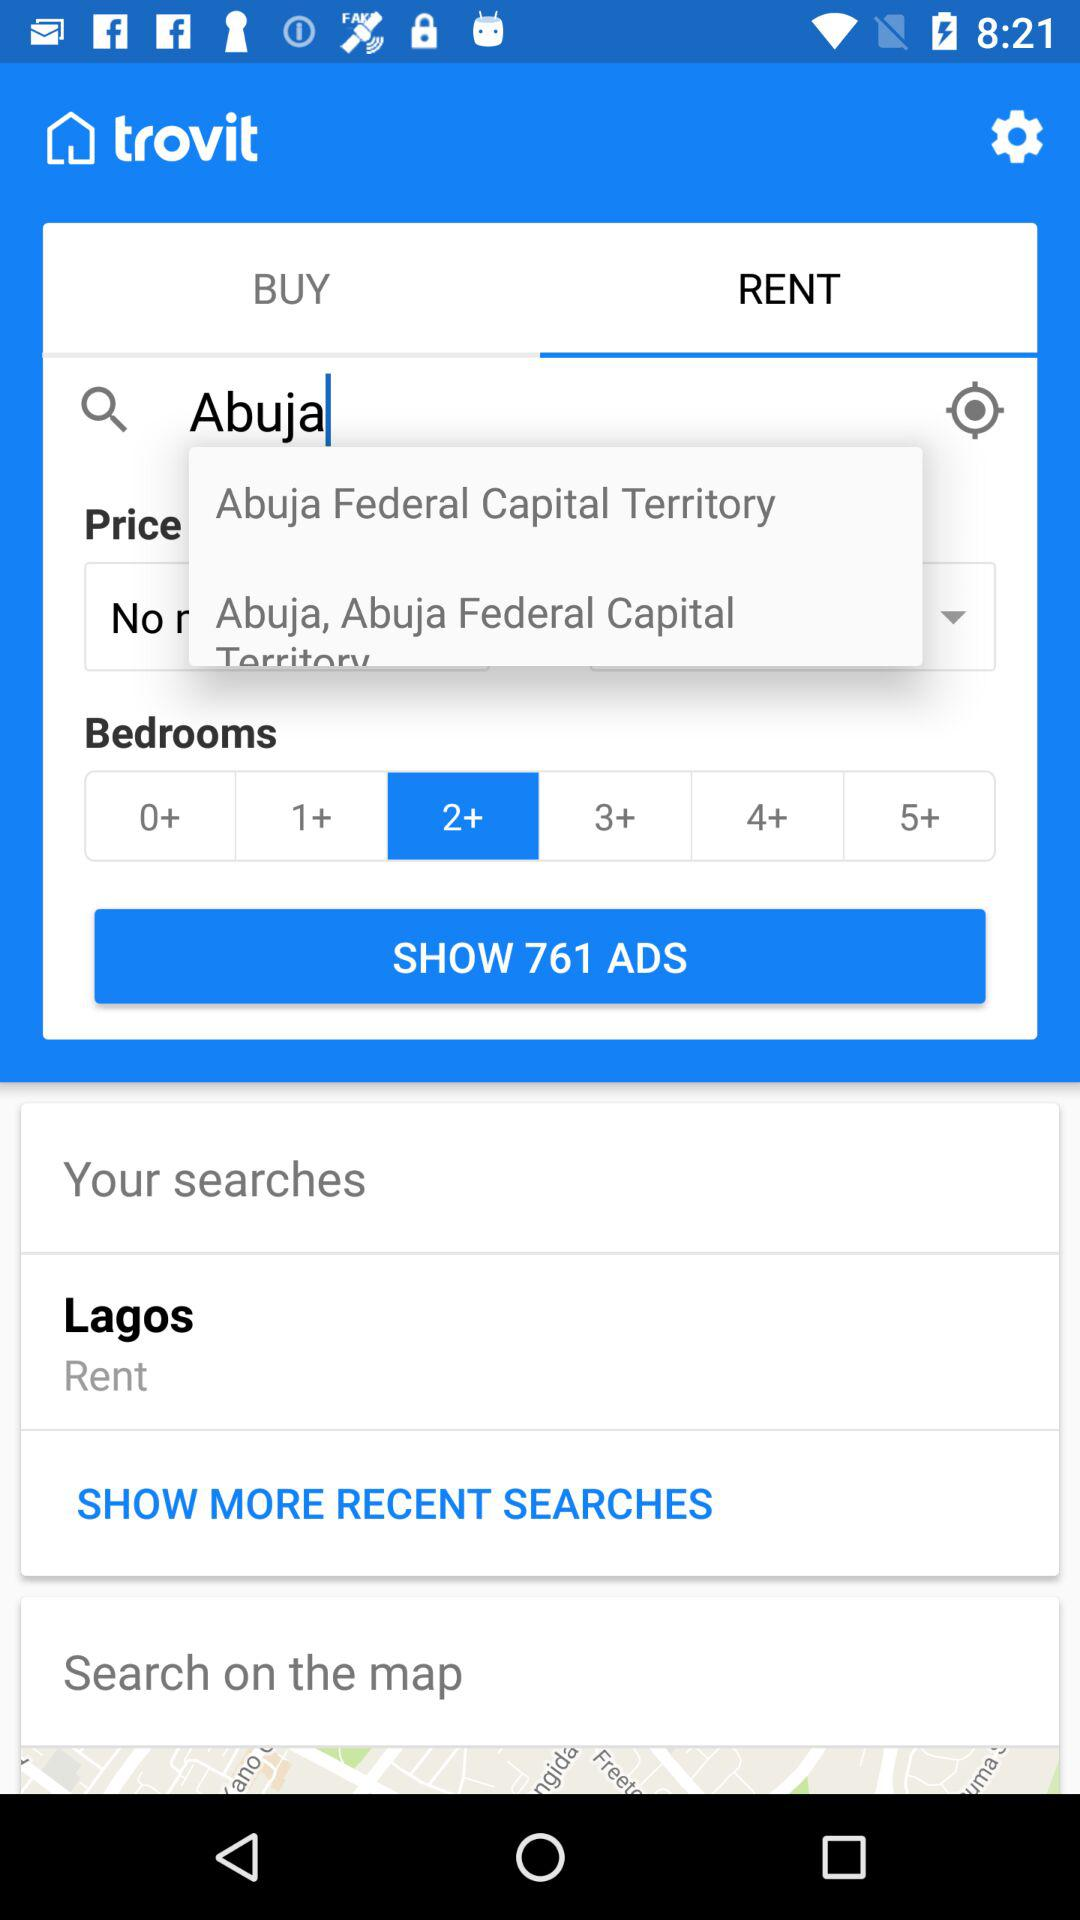How many bedrooms are selected? The selected number of bedrooms is more than 2. 